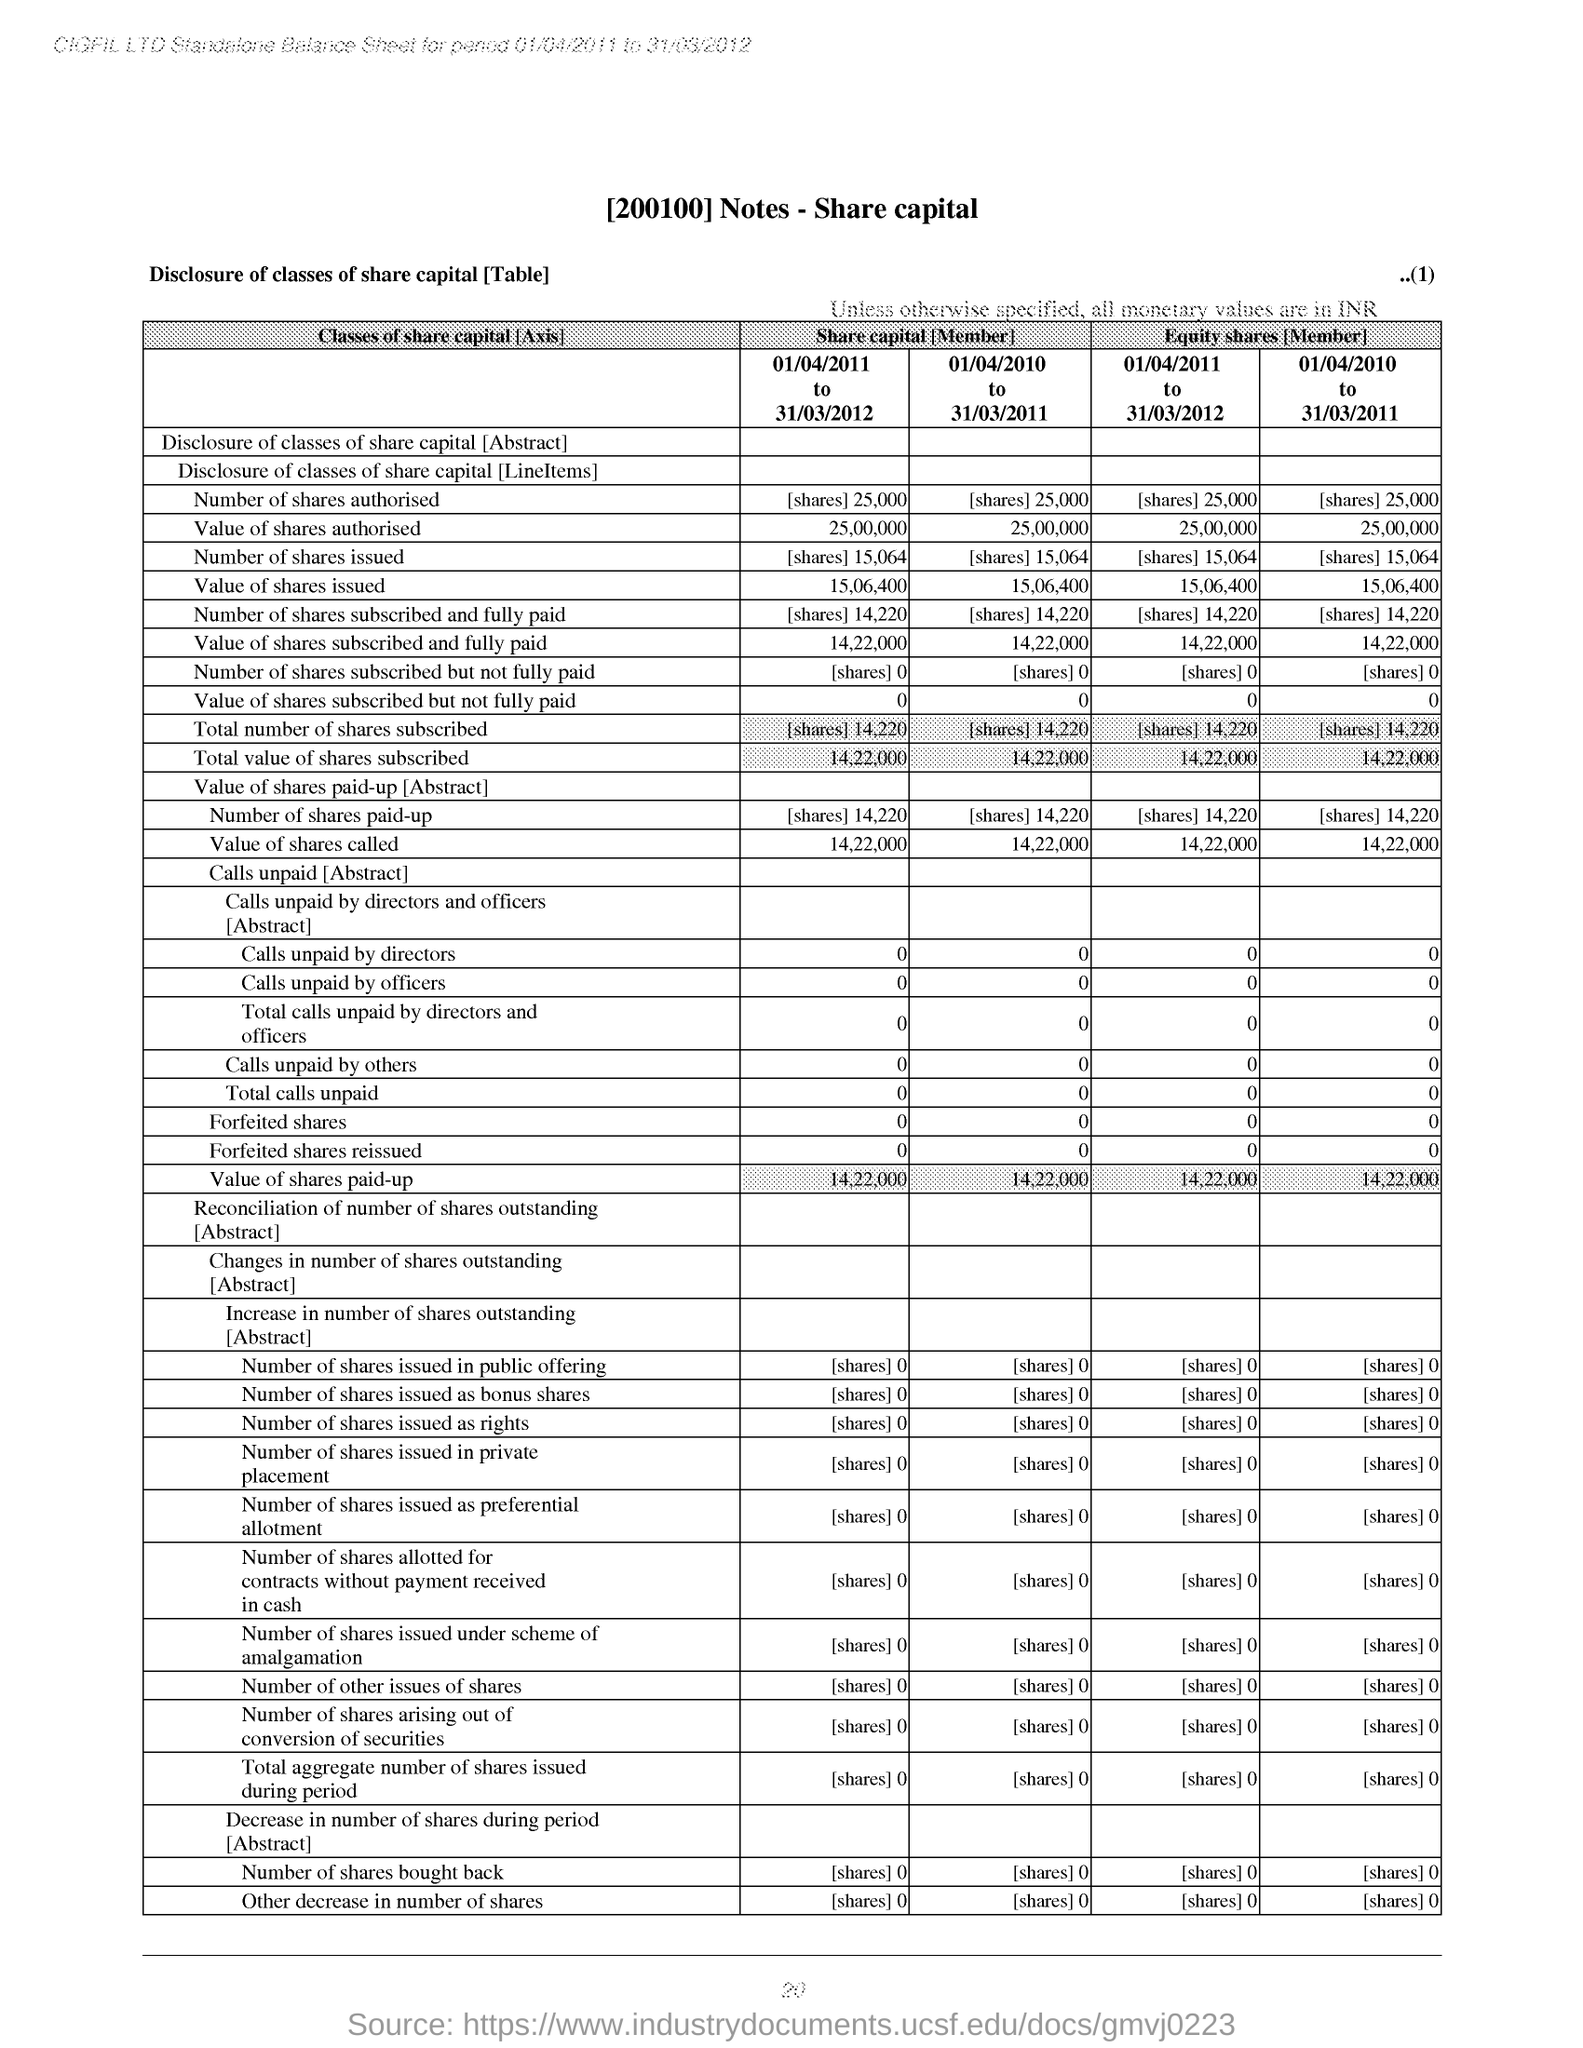Indicate a few pertinent items in this graphic. The page number is 20. 